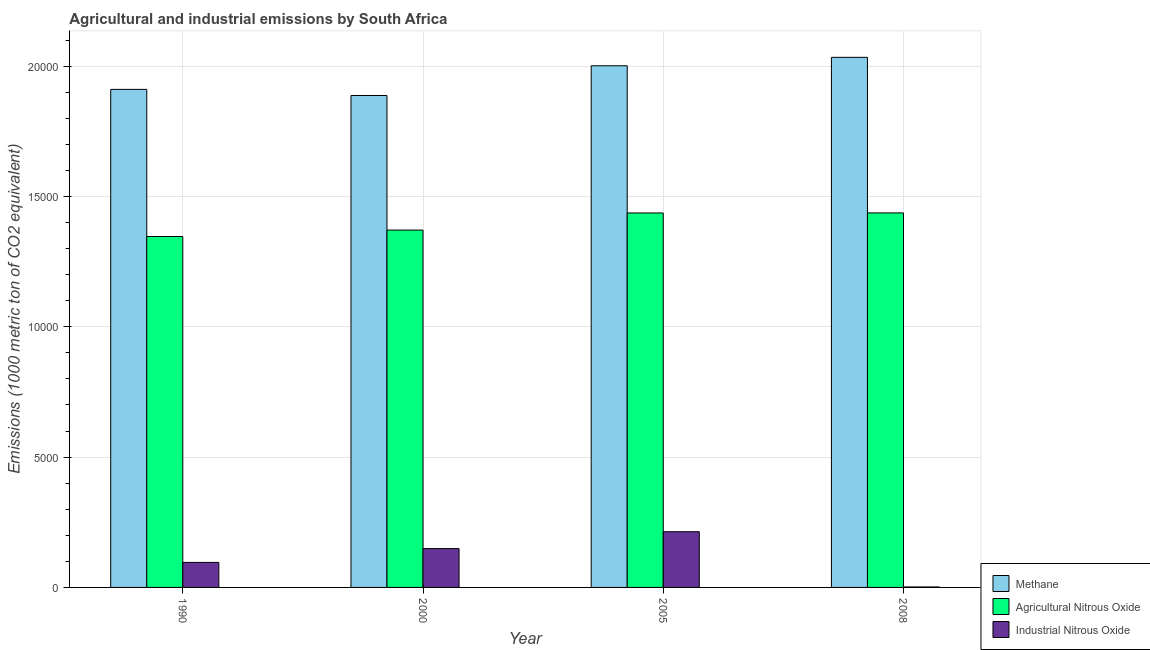How many different coloured bars are there?
Offer a terse response. 3. How many bars are there on the 1st tick from the left?
Your answer should be very brief. 3. What is the label of the 1st group of bars from the left?
Provide a short and direct response. 1990. In how many cases, is the number of bars for a given year not equal to the number of legend labels?
Your answer should be very brief. 0. What is the amount of methane emissions in 2000?
Your answer should be compact. 1.89e+04. Across all years, what is the maximum amount of industrial nitrous oxide emissions?
Ensure brevity in your answer.  2137.4. Across all years, what is the minimum amount of methane emissions?
Make the answer very short. 1.89e+04. In which year was the amount of industrial nitrous oxide emissions maximum?
Your answer should be compact. 2005. In which year was the amount of agricultural nitrous oxide emissions minimum?
Ensure brevity in your answer.  1990. What is the total amount of industrial nitrous oxide emissions in the graph?
Give a very brief answer. 4605. What is the difference between the amount of methane emissions in 1990 and that in 2005?
Offer a terse response. -906.3. What is the difference between the amount of industrial nitrous oxide emissions in 2008 and the amount of methane emissions in 2005?
Your answer should be very brief. -2119.5. What is the average amount of agricultural nitrous oxide emissions per year?
Offer a terse response. 1.40e+04. In the year 1990, what is the difference between the amount of agricultural nitrous oxide emissions and amount of methane emissions?
Your response must be concise. 0. What is the ratio of the amount of industrial nitrous oxide emissions in 1990 to that in 2008?
Your response must be concise. 53.62. Is the amount of industrial nitrous oxide emissions in 1990 less than that in 2005?
Give a very brief answer. Yes. What is the difference between the highest and the second highest amount of methane emissions?
Offer a very short reply. 323.4. What is the difference between the highest and the lowest amount of agricultural nitrous oxide emissions?
Your response must be concise. 905.7. In how many years, is the amount of agricultural nitrous oxide emissions greater than the average amount of agricultural nitrous oxide emissions taken over all years?
Your answer should be very brief. 2. Is the sum of the amount of agricultural nitrous oxide emissions in 1990 and 2008 greater than the maximum amount of methane emissions across all years?
Your response must be concise. Yes. What does the 1st bar from the left in 2005 represents?
Keep it short and to the point. Methane. What does the 1st bar from the right in 1990 represents?
Provide a succinct answer. Industrial Nitrous Oxide. How many bars are there?
Offer a terse response. 12. Are all the bars in the graph horizontal?
Your response must be concise. No. What is the difference between two consecutive major ticks on the Y-axis?
Your answer should be very brief. 5000. Does the graph contain any zero values?
Your response must be concise. No. Does the graph contain grids?
Your response must be concise. Yes. How are the legend labels stacked?
Ensure brevity in your answer.  Vertical. What is the title of the graph?
Provide a short and direct response. Agricultural and industrial emissions by South Africa. Does "Errors" appear as one of the legend labels in the graph?
Your response must be concise. No. What is the label or title of the Y-axis?
Offer a very short reply. Emissions (1000 metric ton of CO2 equivalent). What is the Emissions (1000 metric ton of CO2 equivalent) of Methane in 1990?
Offer a very short reply. 1.91e+04. What is the Emissions (1000 metric ton of CO2 equivalent) of Agricultural Nitrous Oxide in 1990?
Provide a short and direct response. 1.35e+04. What is the Emissions (1000 metric ton of CO2 equivalent) of Industrial Nitrous Oxide in 1990?
Provide a succinct answer. 959.8. What is the Emissions (1000 metric ton of CO2 equivalent) in Methane in 2000?
Provide a short and direct response. 1.89e+04. What is the Emissions (1000 metric ton of CO2 equivalent) of Agricultural Nitrous Oxide in 2000?
Provide a short and direct response. 1.37e+04. What is the Emissions (1000 metric ton of CO2 equivalent) in Industrial Nitrous Oxide in 2000?
Offer a very short reply. 1489.9. What is the Emissions (1000 metric ton of CO2 equivalent) in Methane in 2005?
Provide a short and direct response. 2.00e+04. What is the Emissions (1000 metric ton of CO2 equivalent) in Agricultural Nitrous Oxide in 2005?
Your answer should be compact. 1.44e+04. What is the Emissions (1000 metric ton of CO2 equivalent) in Industrial Nitrous Oxide in 2005?
Make the answer very short. 2137.4. What is the Emissions (1000 metric ton of CO2 equivalent) of Methane in 2008?
Offer a very short reply. 2.03e+04. What is the Emissions (1000 metric ton of CO2 equivalent) of Agricultural Nitrous Oxide in 2008?
Your answer should be compact. 1.44e+04. What is the Emissions (1000 metric ton of CO2 equivalent) in Industrial Nitrous Oxide in 2008?
Your answer should be compact. 17.9. Across all years, what is the maximum Emissions (1000 metric ton of CO2 equivalent) in Methane?
Your response must be concise. 2.03e+04. Across all years, what is the maximum Emissions (1000 metric ton of CO2 equivalent) in Agricultural Nitrous Oxide?
Your answer should be very brief. 1.44e+04. Across all years, what is the maximum Emissions (1000 metric ton of CO2 equivalent) in Industrial Nitrous Oxide?
Your answer should be very brief. 2137.4. Across all years, what is the minimum Emissions (1000 metric ton of CO2 equivalent) in Methane?
Offer a very short reply. 1.89e+04. Across all years, what is the minimum Emissions (1000 metric ton of CO2 equivalent) of Agricultural Nitrous Oxide?
Your answer should be very brief. 1.35e+04. What is the total Emissions (1000 metric ton of CO2 equivalent) in Methane in the graph?
Ensure brevity in your answer.  7.83e+04. What is the total Emissions (1000 metric ton of CO2 equivalent) of Agricultural Nitrous Oxide in the graph?
Keep it short and to the point. 5.59e+04. What is the total Emissions (1000 metric ton of CO2 equivalent) of Industrial Nitrous Oxide in the graph?
Your answer should be very brief. 4605. What is the difference between the Emissions (1000 metric ton of CO2 equivalent) in Methane in 1990 and that in 2000?
Make the answer very short. 234.6. What is the difference between the Emissions (1000 metric ton of CO2 equivalent) in Agricultural Nitrous Oxide in 1990 and that in 2000?
Offer a very short reply. -246.5. What is the difference between the Emissions (1000 metric ton of CO2 equivalent) in Industrial Nitrous Oxide in 1990 and that in 2000?
Your response must be concise. -530.1. What is the difference between the Emissions (1000 metric ton of CO2 equivalent) of Methane in 1990 and that in 2005?
Offer a terse response. -906.3. What is the difference between the Emissions (1000 metric ton of CO2 equivalent) of Agricultural Nitrous Oxide in 1990 and that in 2005?
Offer a very short reply. -903.7. What is the difference between the Emissions (1000 metric ton of CO2 equivalent) in Industrial Nitrous Oxide in 1990 and that in 2005?
Keep it short and to the point. -1177.6. What is the difference between the Emissions (1000 metric ton of CO2 equivalent) of Methane in 1990 and that in 2008?
Provide a succinct answer. -1229.7. What is the difference between the Emissions (1000 metric ton of CO2 equivalent) of Agricultural Nitrous Oxide in 1990 and that in 2008?
Your response must be concise. -905.7. What is the difference between the Emissions (1000 metric ton of CO2 equivalent) of Industrial Nitrous Oxide in 1990 and that in 2008?
Keep it short and to the point. 941.9. What is the difference between the Emissions (1000 metric ton of CO2 equivalent) of Methane in 2000 and that in 2005?
Provide a short and direct response. -1140.9. What is the difference between the Emissions (1000 metric ton of CO2 equivalent) in Agricultural Nitrous Oxide in 2000 and that in 2005?
Your answer should be very brief. -657.2. What is the difference between the Emissions (1000 metric ton of CO2 equivalent) in Industrial Nitrous Oxide in 2000 and that in 2005?
Provide a succinct answer. -647.5. What is the difference between the Emissions (1000 metric ton of CO2 equivalent) of Methane in 2000 and that in 2008?
Your response must be concise. -1464.3. What is the difference between the Emissions (1000 metric ton of CO2 equivalent) in Agricultural Nitrous Oxide in 2000 and that in 2008?
Offer a terse response. -659.2. What is the difference between the Emissions (1000 metric ton of CO2 equivalent) in Industrial Nitrous Oxide in 2000 and that in 2008?
Provide a short and direct response. 1472. What is the difference between the Emissions (1000 metric ton of CO2 equivalent) in Methane in 2005 and that in 2008?
Provide a succinct answer. -323.4. What is the difference between the Emissions (1000 metric ton of CO2 equivalent) in Industrial Nitrous Oxide in 2005 and that in 2008?
Your response must be concise. 2119.5. What is the difference between the Emissions (1000 metric ton of CO2 equivalent) of Methane in 1990 and the Emissions (1000 metric ton of CO2 equivalent) of Agricultural Nitrous Oxide in 2000?
Provide a succinct answer. 5398.3. What is the difference between the Emissions (1000 metric ton of CO2 equivalent) of Methane in 1990 and the Emissions (1000 metric ton of CO2 equivalent) of Industrial Nitrous Oxide in 2000?
Provide a short and direct response. 1.76e+04. What is the difference between the Emissions (1000 metric ton of CO2 equivalent) in Agricultural Nitrous Oxide in 1990 and the Emissions (1000 metric ton of CO2 equivalent) in Industrial Nitrous Oxide in 2000?
Your answer should be compact. 1.20e+04. What is the difference between the Emissions (1000 metric ton of CO2 equivalent) in Methane in 1990 and the Emissions (1000 metric ton of CO2 equivalent) in Agricultural Nitrous Oxide in 2005?
Provide a succinct answer. 4741.1. What is the difference between the Emissions (1000 metric ton of CO2 equivalent) of Methane in 1990 and the Emissions (1000 metric ton of CO2 equivalent) of Industrial Nitrous Oxide in 2005?
Ensure brevity in your answer.  1.70e+04. What is the difference between the Emissions (1000 metric ton of CO2 equivalent) of Agricultural Nitrous Oxide in 1990 and the Emissions (1000 metric ton of CO2 equivalent) of Industrial Nitrous Oxide in 2005?
Ensure brevity in your answer.  1.13e+04. What is the difference between the Emissions (1000 metric ton of CO2 equivalent) of Methane in 1990 and the Emissions (1000 metric ton of CO2 equivalent) of Agricultural Nitrous Oxide in 2008?
Offer a very short reply. 4739.1. What is the difference between the Emissions (1000 metric ton of CO2 equivalent) of Methane in 1990 and the Emissions (1000 metric ton of CO2 equivalent) of Industrial Nitrous Oxide in 2008?
Keep it short and to the point. 1.91e+04. What is the difference between the Emissions (1000 metric ton of CO2 equivalent) of Agricultural Nitrous Oxide in 1990 and the Emissions (1000 metric ton of CO2 equivalent) of Industrial Nitrous Oxide in 2008?
Make the answer very short. 1.34e+04. What is the difference between the Emissions (1000 metric ton of CO2 equivalent) of Methane in 2000 and the Emissions (1000 metric ton of CO2 equivalent) of Agricultural Nitrous Oxide in 2005?
Provide a short and direct response. 4506.5. What is the difference between the Emissions (1000 metric ton of CO2 equivalent) of Methane in 2000 and the Emissions (1000 metric ton of CO2 equivalent) of Industrial Nitrous Oxide in 2005?
Ensure brevity in your answer.  1.67e+04. What is the difference between the Emissions (1000 metric ton of CO2 equivalent) of Agricultural Nitrous Oxide in 2000 and the Emissions (1000 metric ton of CO2 equivalent) of Industrial Nitrous Oxide in 2005?
Your answer should be very brief. 1.16e+04. What is the difference between the Emissions (1000 metric ton of CO2 equivalent) of Methane in 2000 and the Emissions (1000 metric ton of CO2 equivalent) of Agricultural Nitrous Oxide in 2008?
Offer a terse response. 4504.5. What is the difference between the Emissions (1000 metric ton of CO2 equivalent) of Methane in 2000 and the Emissions (1000 metric ton of CO2 equivalent) of Industrial Nitrous Oxide in 2008?
Provide a short and direct response. 1.89e+04. What is the difference between the Emissions (1000 metric ton of CO2 equivalent) of Agricultural Nitrous Oxide in 2000 and the Emissions (1000 metric ton of CO2 equivalent) of Industrial Nitrous Oxide in 2008?
Your answer should be compact. 1.37e+04. What is the difference between the Emissions (1000 metric ton of CO2 equivalent) of Methane in 2005 and the Emissions (1000 metric ton of CO2 equivalent) of Agricultural Nitrous Oxide in 2008?
Make the answer very short. 5645.4. What is the difference between the Emissions (1000 metric ton of CO2 equivalent) in Methane in 2005 and the Emissions (1000 metric ton of CO2 equivalent) in Industrial Nitrous Oxide in 2008?
Offer a terse response. 2.00e+04. What is the difference between the Emissions (1000 metric ton of CO2 equivalent) of Agricultural Nitrous Oxide in 2005 and the Emissions (1000 metric ton of CO2 equivalent) of Industrial Nitrous Oxide in 2008?
Provide a succinct answer. 1.43e+04. What is the average Emissions (1000 metric ton of CO2 equivalent) of Methane per year?
Make the answer very short. 1.96e+04. What is the average Emissions (1000 metric ton of CO2 equivalent) of Agricultural Nitrous Oxide per year?
Offer a very short reply. 1.40e+04. What is the average Emissions (1000 metric ton of CO2 equivalent) in Industrial Nitrous Oxide per year?
Ensure brevity in your answer.  1151.25. In the year 1990, what is the difference between the Emissions (1000 metric ton of CO2 equivalent) in Methane and Emissions (1000 metric ton of CO2 equivalent) in Agricultural Nitrous Oxide?
Give a very brief answer. 5644.8. In the year 1990, what is the difference between the Emissions (1000 metric ton of CO2 equivalent) of Methane and Emissions (1000 metric ton of CO2 equivalent) of Industrial Nitrous Oxide?
Offer a terse response. 1.81e+04. In the year 1990, what is the difference between the Emissions (1000 metric ton of CO2 equivalent) in Agricultural Nitrous Oxide and Emissions (1000 metric ton of CO2 equivalent) in Industrial Nitrous Oxide?
Your response must be concise. 1.25e+04. In the year 2000, what is the difference between the Emissions (1000 metric ton of CO2 equivalent) of Methane and Emissions (1000 metric ton of CO2 equivalent) of Agricultural Nitrous Oxide?
Give a very brief answer. 5163.7. In the year 2000, what is the difference between the Emissions (1000 metric ton of CO2 equivalent) of Methane and Emissions (1000 metric ton of CO2 equivalent) of Industrial Nitrous Oxide?
Your response must be concise. 1.74e+04. In the year 2000, what is the difference between the Emissions (1000 metric ton of CO2 equivalent) in Agricultural Nitrous Oxide and Emissions (1000 metric ton of CO2 equivalent) in Industrial Nitrous Oxide?
Your response must be concise. 1.22e+04. In the year 2005, what is the difference between the Emissions (1000 metric ton of CO2 equivalent) in Methane and Emissions (1000 metric ton of CO2 equivalent) in Agricultural Nitrous Oxide?
Keep it short and to the point. 5647.4. In the year 2005, what is the difference between the Emissions (1000 metric ton of CO2 equivalent) of Methane and Emissions (1000 metric ton of CO2 equivalent) of Industrial Nitrous Oxide?
Your response must be concise. 1.79e+04. In the year 2005, what is the difference between the Emissions (1000 metric ton of CO2 equivalent) of Agricultural Nitrous Oxide and Emissions (1000 metric ton of CO2 equivalent) of Industrial Nitrous Oxide?
Give a very brief answer. 1.22e+04. In the year 2008, what is the difference between the Emissions (1000 metric ton of CO2 equivalent) in Methane and Emissions (1000 metric ton of CO2 equivalent) in Agricultural Nitrous Oxide?
Make the answer very short. 5968.8. In the year 2008, what is the difference between the Emissions (1000 metric ton of CO2 equivalent) of Methane and Emissions (1000 metric ton of CO2 equivalent) of Industrial Nitrous Oxide?
Ensure brevity in your answer.  2.03e+04. In the year 2008, what is the difference between the Emissions (1000 metric ton of CO2 equivalent) in Agricultural Nitrous Oxide and Emissions (1000 metric ton of CO2 equivalent) in Industrial Nitrous Oxide?
Your response must be concise. 1.44e+04. What is the ratio of the Emissions (1000 metric ton of CO2 equivalent) of Methane in 1990 to that in 2000?
Your answer should be very brief. 1.01. What is the ratio of the Emissions (1000 metric ton of CO2 equivalent) of Industrial Nitrous Oxide in 1990 to that in 2000?
Make the answer very short. 0.64. What is the ratio of the Emissions (1000 metric ton of CO2 equivalent) in Methane in 1990 to that in 2005?
Offer a terse response. 0.95. What is the ratio of the Emissions (1000 metric ton of CO2 equivalent) of Agricultural Nitrous Oxide in 1990 to that in 2005?
Offer a very short reply. 0.94. What is the ratio of the Emissions (1000 metric ton of CO2 equivalent) in Industrial Nitrous Oxide in 1990 to that in 2005?
Provide a succinct answer. 0.45. What is the ratio of the Emissions (1000 metric ton of CO2 equivalent) in Methane in 1990 to that in 2008?
Ensure brevity in your answer.  0.94. What is the ratio of the Emissions (1000 metric ton of CO2 equivalent) in Agricultural Nitrous Oxide in 1990 to that in 2008?
Provide a short and direct response. 0.94. What is the ratio of the Emissions (1000 metric ton of CO2 equivalent) in Industrial Nitrous Oxide in 1990 to that in 2008?
Provide a succinct answer. 53.62. What is the ratio of the Emissions (1000 metric ton of CO2 equivalent) of Methane in 2000 to that in 2005?
Offer a very short reply. 0.94. What is the ratio of the Emissions (1000 metric ton of CO2 equivalent) in Agricultural Nitrous Oxide in 2000 to that in 2005?
Make the answer very short. 0.95. What is the ratio of the Emissions (1000 metric ton of CO2 equivalent) of Industrial Nitrous Oxide in 2000 to that in 2005?
Your answer should be very brief. 0.7. What is the ratio of the Emissions (1000 metric ton of CO2 equivalent) of Methane in 2000 to that in 2008?
Your answer should be very brief. 0.93. What is the ratio of the Emissions (1000 metric ton of CO2 equivalent) in Agricultural Nitrous Oxide in 2000 to that in 2008?
Offer a terse response. 0.95. What is the ratio of the Emissions (1000 metric ton of CO2 equivalent) of Industrial Nitrous Oxide in 2000 to that in 2008?
Ensure brevity in your answer.  83.23. What is the ratio of the Emissions (1000 metric ton of CO2 equivalent) in Methane in 2005 to that in 2008?
Provide a short and direct response. 0.98. What is the ratio of the Emissions (1000 metric ton of CO2 equivalent) in Agricultural Nitrous Oxide in 2005 to that in 2008?
Make the answer very short. 1. What is the ratio of the Emissions (1000 metric ton of CO2 equivalent) in Industrial Nitrous Oxide in 2005 to that in 2008?
Ensure brevity in your answer.  119.41. What is the difference between the highest and the second highest Emissions (1000 metric ton of CO2 equivalent) of Methane?
Ensure brevity in your answer.  323.4. What is the difference between the highest and the second highest Emissions (1000 metric ton of CO2 equivalent) in Agricultural Nitrous Oxide?
Your answer should be compact. 2. What is the difference between the highest and the second highest Emissions (1000 metric ton of CO2 equivalent) in Industrial Nitrous Oxide?
Provide a short and direct response. 647.5. What is the difference between the highest and the lowest Emissions (1000 metric ton of CO2 equivalent) of Methane?
Keep it short and to the point. 1464.3. What is the difference between the highest and the lowest Emissions (1000 metric ton of CO2 equivalent) in Agricultural Nitrous Oxide?
Keep it short and to the point. 905.7. What is the difference between the highest and the lowest Emissions (1000 metric ton of CO2 equivalent) of Industrial Nitrous Oxide?
Offer a very short reply. 2119.5. 